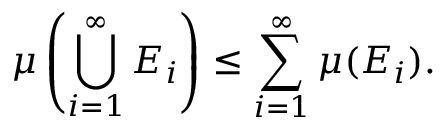Convert formula to latex. <formula><loc_0><loc_0><loc_500><loc_500>\mu \left ( \bigcup _ { i = 1 } ^ { \infty } E _ { i } \right ) \leq \sum _ { i = 1 } ^ { \infty } \mu ( E _ { i } ) .</formula> 